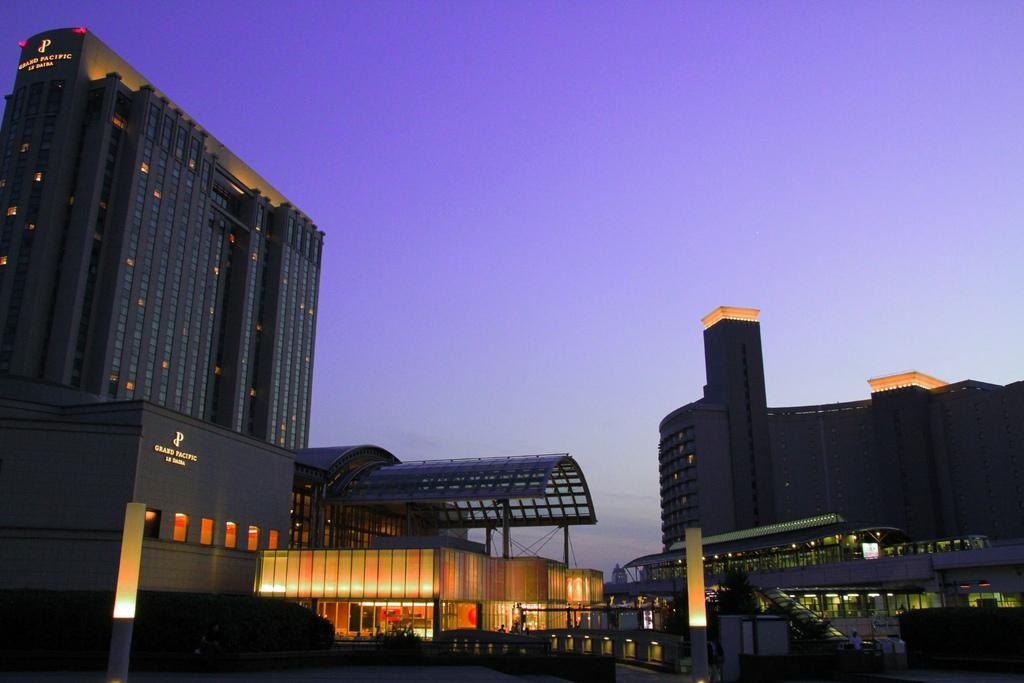What type of structure is in the picture? There is a building in the picture. What feature can be observed on the building? The building has glass windows. Is there any signage on the building? Yes, there is a name board on the building. What is visible on the right side of the picture? There is another building on the right side of the picture. How would you describe the weather based on the image? The sky is clear in the image, suggesting good weather. Can you tell me how many yards of butter are stored in the building? There is no information about butter or any storage in the building in the image. How many wings are visible on the building in the image? The building in the image has a rectangular shape, and there are no visible wings. 